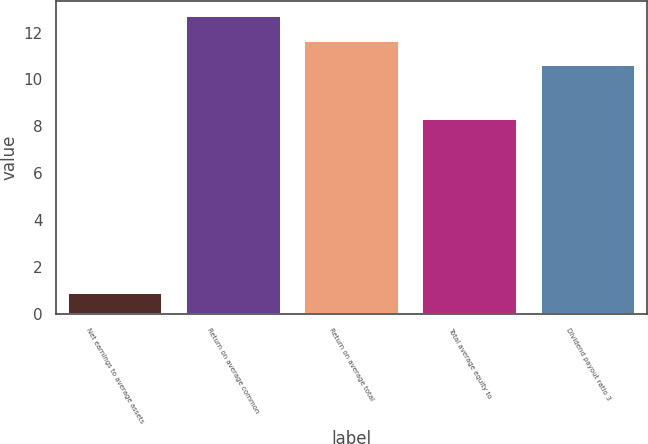Convert chart to OTSL. <chart><loc_0><loc_0><loc_500><loc_500><bar_chart><fcel>Net earnings to average assets<fcel>Return on average common<fcel>Return on average total<fcel>Total average equity to<fcel>Dividend payout ratio 3<nl><fcel>0.9<fcel>12.72<fcel>11.66<fcel>8.3<fcel>10.6<nl></chart> 